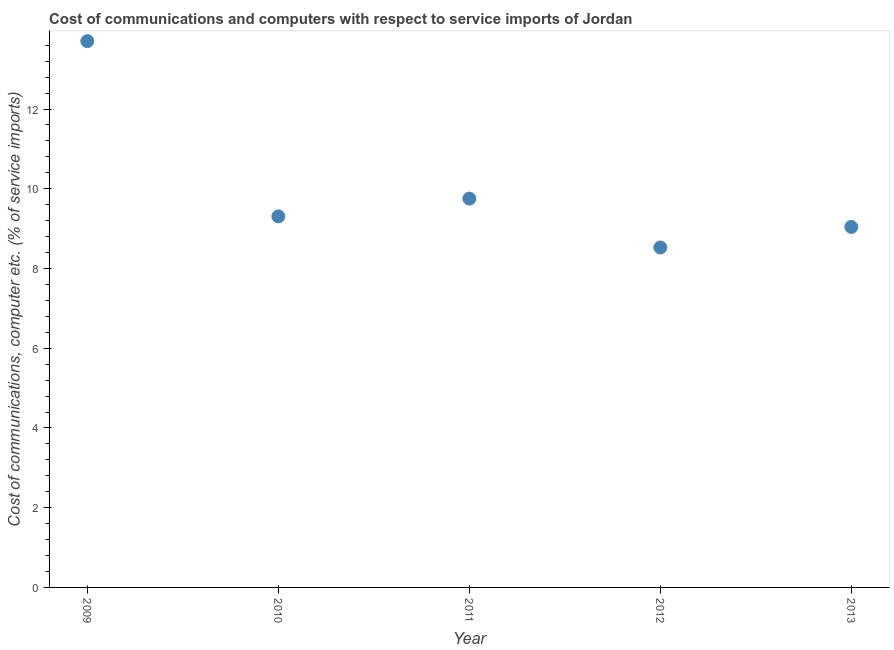What is the cost of communications and computer in 2011?
Offer a very short reply. 9.75. Across all years, what is the maximum cost of communications and computer?
Keep it short and to the point. 13.7. Across all years, what is the minimum cost of communications and computer?
Your answer should be compact. 8.53. In which year was the cost of communications and computer minimum?
Your response must be concise. 2012. What is the sum of the cost of communications and computer?
Offer a very short reply. 50.33. What is the difference between the cost of communications and computer in 2009 and 2011?
Your response must be concise. 3.95. What is the average cost of communications and computer per year?
Your answer should be compact. 10.07. What is the median cost of communications and computer?
Provide a short and direct response. 9.31. Do a majority of the years between 2012 and 2011 (inclusive) have cost of communications and computer greater than 12.4 %?
Keep it short and to the point. No. What is the ratio of the cost of communications and computer in 2011 to that in 2013?
Your response must be concise. 1.08. What is the difference between the highest and the second highest cost of communications and computer?
Make the answer very short. 3.95. Is the sum of the cost of communications and computer in 2010 and 2011 greater than the maximum cost of communications and computer across all years?
Keep it short and to the point. Yes. What is the difference between the highest and the lowest cost of communications and computer?
Give a very brief answer. 5.18. In how many years, is the cost of communications and computer greater than the average cost of communications and computer taken over all years?
Your response must be concise. 1. How many dotlines are there?
Provide a short and direct response. 1. How many years are there in the graph?
Make the answer very short. 5. What is the difference between two consecutive major ticks on the Y-axis?
Your answer should be compact. 2. Are the values on the major ticks of Y-axis written in scientific E-notation?
Give a very brief answer. No. Does the graph contain any zero values?
Your answer should be very brief. No. Does the graph contain grids?
Ensure brevity in your answer.  No. What is the title of the graph?
Ensure brevity in your answer.  Cost of communications and computers with respect to service imports of Jordan. What is the label or title of the X-axis?
Offer a very short reply. Year. What is the label or title of the Y-axis?
Make the answer very short. Cost of communications, computer etc. (% of service imports). What is the Cost of communications, computer etc. (% of service imports) in 2009?
Your response must be concise. 13.7. What is the Cost of communications, computer etc. (% of service imports) in 2010?
Provide a succinct answer. 9.31. What is the Cost of communications, computer etc. (% of service imports) in 2011?
Make the answer very short. 9.75. What is the Cost of communications, computer etc. (% of service imports) in 2012?
Your answer should be compact. 8.53. What is the Cost of communications, computer etc. (% of service imports) in 2013?
Your answer should be compact. 9.04. What is the difference between the Cost of communications, computer etc. (% of service imports) in 2009 and 2010?
Your answer should be compact. 4.4. What is the difference between the Cost of communications, computer etc. (% of service imports) in 2009 and 2011?
Keep it short and to the point. 3.95. What is the difference between the Cost of communications, computer etc. (% of service imports) in 2009 and 2012?
Offer a terse response. 5.18. What is the difference between the Cost of communications, computer etc. (% of service imports) in 2009 and 2013?
Offer a terse response. 4.66. What is the difference between the Cost of communications, computer etc. (% of service imports) in 2010 and 2011?
Offer a very short reply. -0.45. What is the difference between the Cost of communications, computer etc. (% of service imports) in 2010 and 2012?
Keep it short and to the point. 0.78. What is the difference between the Cost of communications, computer etc. (% of service imports) in 2010 and 2013?
Your answer should be very brief. 0.27. What is the difference between the Cost of communications, computer etc. (% of service imports) in 2011 and 2012?
Your response must be concise. 1.23. What is the difference between the Cost of communications, computer etc. (% of service imports) in 2011 and 2013?
Give a very brief answer. 0.71. What is the difference between the Cost of communications, computer etc. (% of service imports) in 2012 and 2013?
Keep it short and to the point. -0.52. What is the ratio of the Cost of communications, computer etc. (% of service imports) in 2009 to that in 2010?
Your answer should be compact. 1.47. What is the ratio of the Cost of communications, computer etc. (% of service imports) in 2009 to that in 2011?
Provide a succinct answer. 1.41. What is the ratio of the Cost of communications, computer etc. (% of service imports) in 2009 to that in 2012?
Give a very brief answer. 1.61. What is the ratio of the Cost of communications, computer etc. (% of service imports) in 2009 to that in 2013?
Make the answer very short. 1.51. What is the ratio of the Cost of communications, computer etc. (% of service imports) in 2010 to that in 2011?
Keep it short and to the point. 0.95. What is the ratio of the Cost of communications, computer etc. (% of service imports) in 2010 to that in 2012?
Make the answer very short. 1.09. What is the ratio of the Cost of communications, computer etc. (% of service imports) in 2010 to that in 2013?
Offer a very short reply. 1.03. What is the ratio of the Cost of communications, computer etc. (% of service imports) in 2011 to that in 2012?
Keep it short and to the point. 1.14. What is the ratio of the Cost of communications, computer etc. (% of service imports) in 2011 to that in 2013?
Provide a short and direct response. 1.08. What is the ratio of the Cost of communications, computer etc. (% of service imports) in 2012 to that in 2013?
Keep it short and to the point. 0.94. 